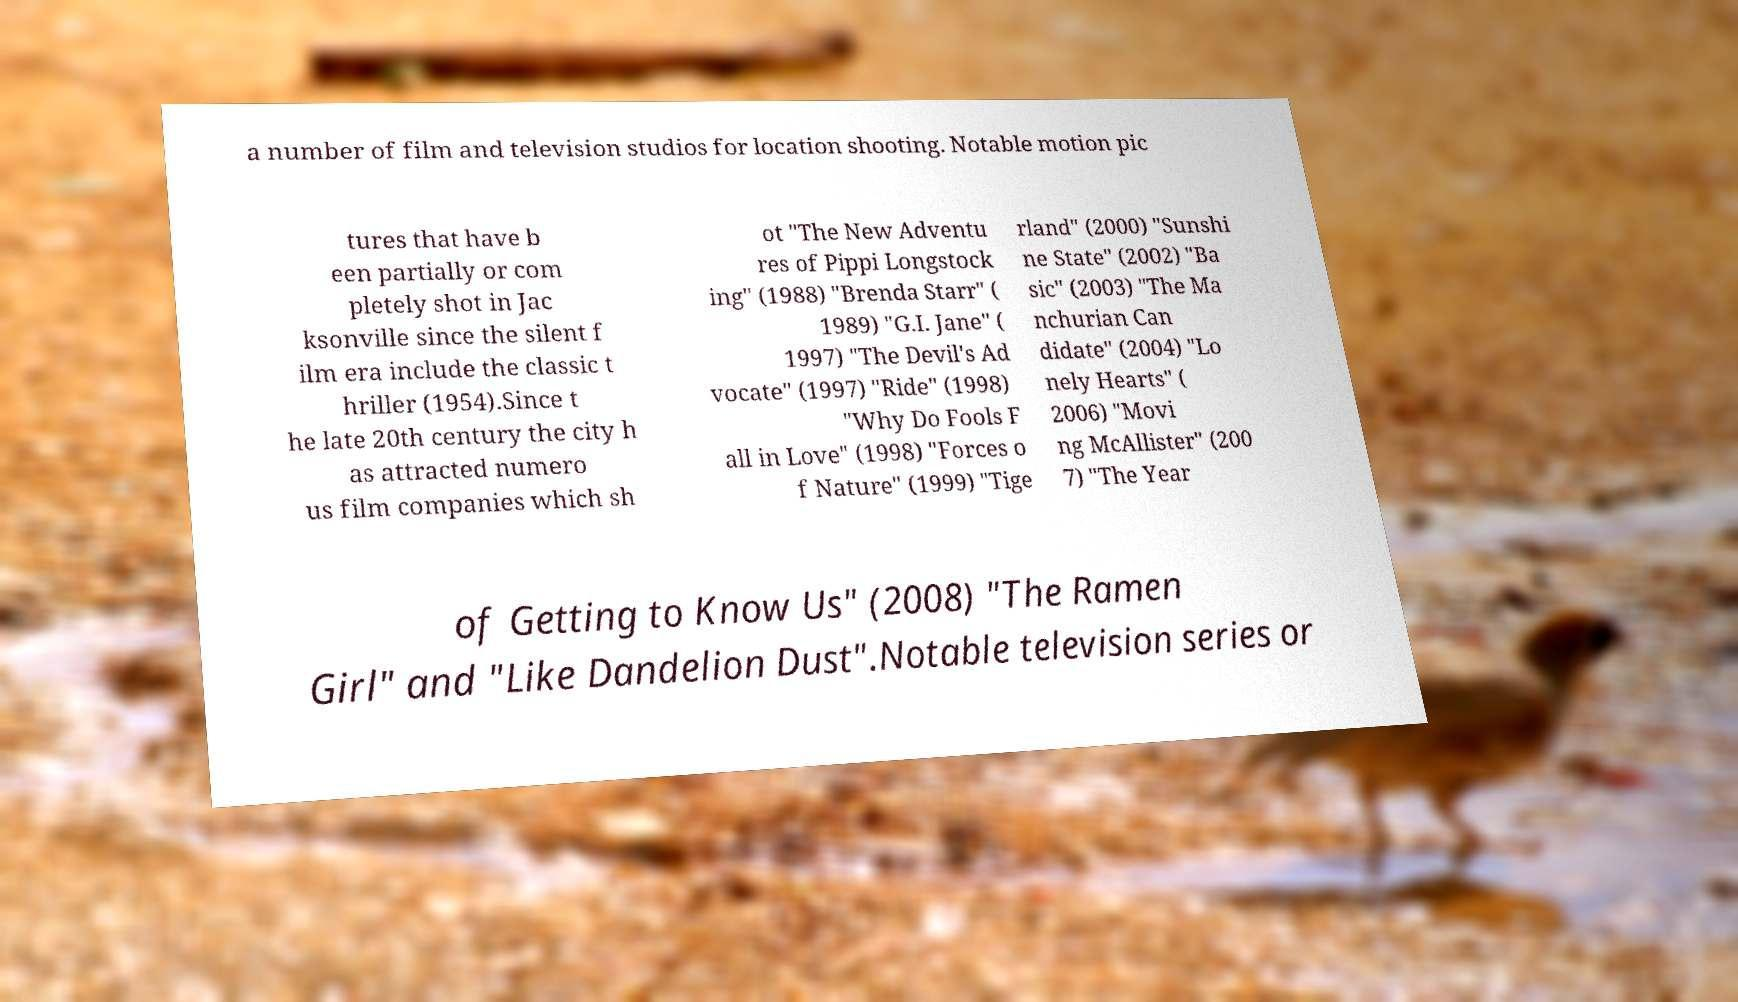Can you accurately transcribe the text from the provided image for me? a number of film and television studios for location shooting. Notable motion pic tures that have b een partially or com pletely shot in Jac ksonville since the silent f ilm era include the classic t hriller (1954).Since t he late 20th century the city h as attracted numero us film companies which sh ot "The New Adventu res of Pippi Longstock ing" (1988) "Brenda Starr" ( 1989) "G.I. Jane" ( 1997) "The Devil's Ad vocate" (1997) "Ride" (1998) "Why Do Fools F all in Love" (1998) "Forces o f Nature" (1999) "Tige rland" (2000) "Sunshi ne State" (2002) "Ba sic" (2003) "The Ma nchurian Can didate" (2004) "Lo nely Hearts" ( 2006) "Movi ng McAllister" (200 7) "The Year of Getting to Know Us" (2008) "The Ramen Girl" and "Like Dandelion Dust".Notable television series or 